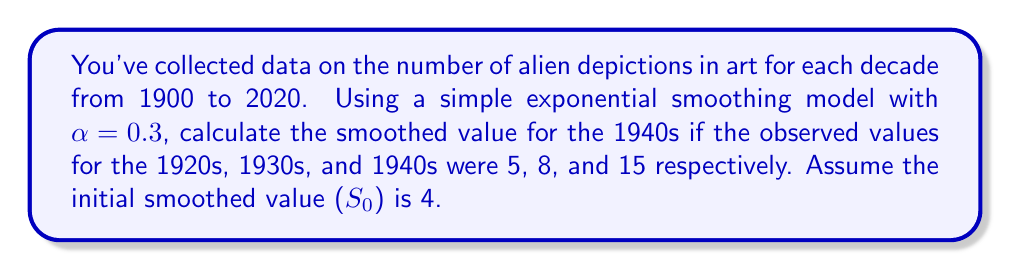Provide a solution to this math problem. To solve this problem, we'll use the simple exponential smoothing formula:

$$S_t = \alpha X_t + (1-\alpha)S_{t-1}$$

Where:
$S_t$ is the smoothed value at time $t$
$X_t$ is the observed value at time $t$
$\alpha$ is the smoothing factor (0 < $\alpha$ < 1)

Given:
$\alpha = 0.3$
$S_0 = 4$ (initial smoothed value)
$X_{1920s} = 5$
$X_{1930s} = 8$
$X_{1940s} = 15$

Step 1: Calculate $S_{1920s}$
$$S_{1920s} = 0.3(5) + (1-0.3)(4) = 1.5 + 2.8 = 4.3$$

Step 2: Calculate $S_{1930s}$
$$S_{1930s} = 0.3(8) + (1-0.3)(4.3) = 2.4 + 3.01 = 5.41$$

Step 3: Calculate $S_{1940s}$ (final answer)
$$S_{1940s} = 0.3(15) + (1-0.3)(5.41) = 4.5 + 3.787 = 8.287$$

The smoothed value for the 1940s is approximately 8.29.
Answer: 8.29 